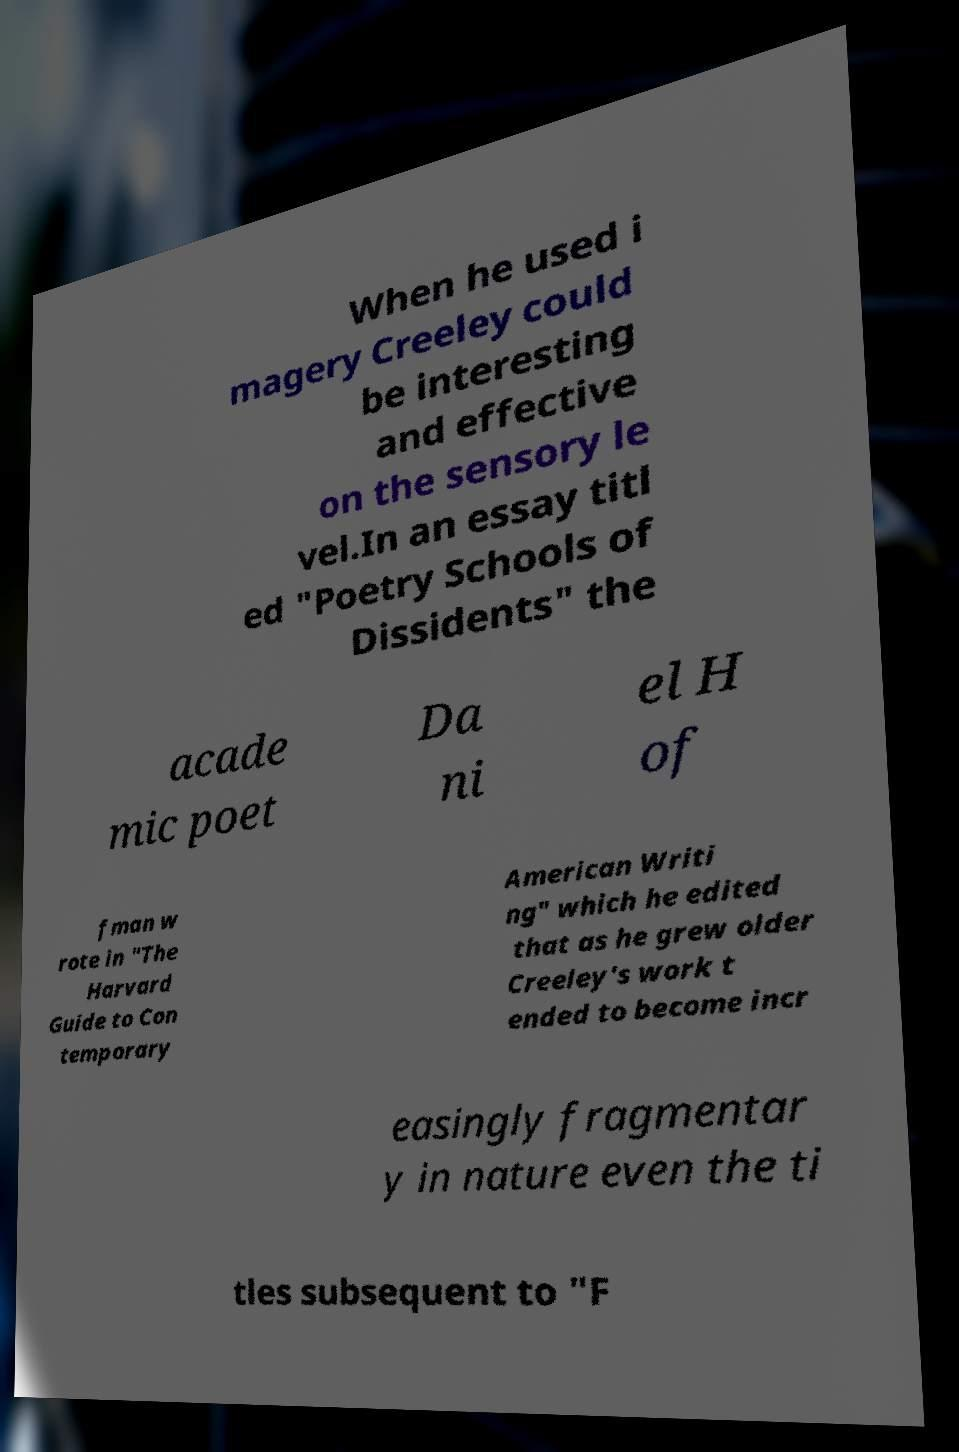What messages or text are displayed in this image? I need them in a readable, typed format. When he used i magery Creeley could be interesting and effective on the sensory le vel.In an essay titl ed "Poetry Schools of Dissidents" the acade mic poet Da ni el H of fman w rote in "The Harvard Guide to Con temporary American Writi ng" which he edited that as he grew older Creeley's work t ended to become incr easingly fragmentar y in nature even the ti tles subsequent to "F 